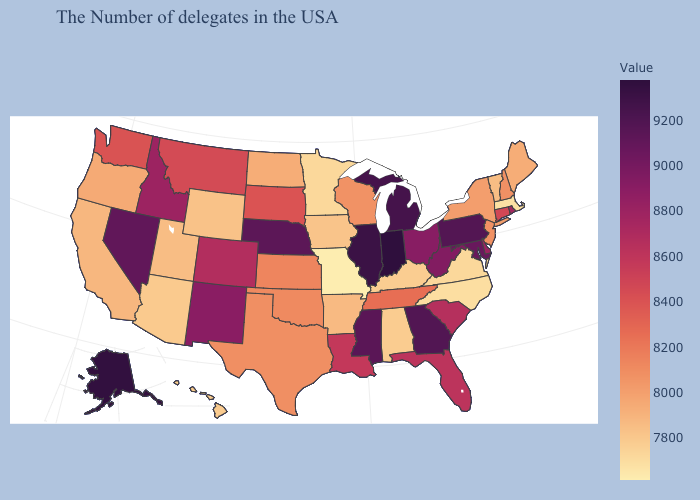Does Nevada have a lower value than Kansas?
Keep it brief. No. Which states hav the highest value in the MidWest?
Write a very short answer. Indiana. Is the legend a continuous bar?
Short answer required. Yes. Which states have the highest value in the USA?
Be succinct. Indiana. 